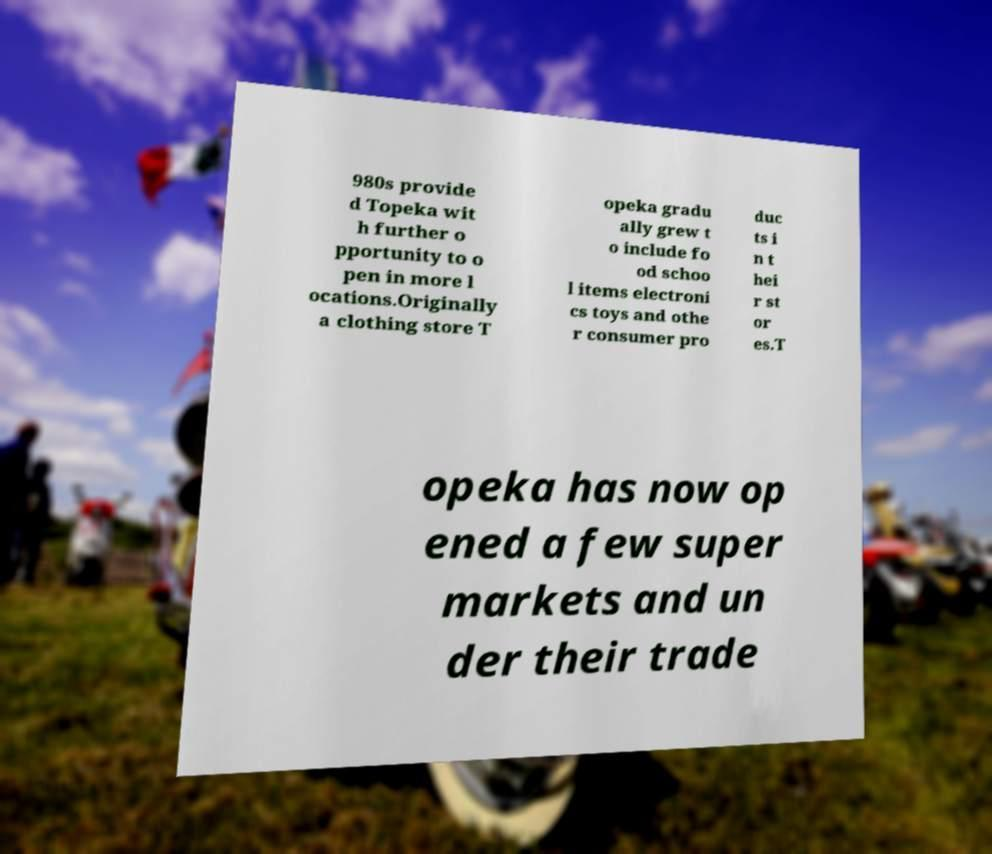Can you accurately transcribe the text from the provided image for me? 980s provide d Topeka wit h further o pportunity to o pen in more l ocations.Originally a clothing store T opeka gradu ally grew t o include fo od schoo l items electroni cs toys and othe r consumer pro duc ts i n t hei r st or es.T opeka has now op ened a few super markets and un der their trade 